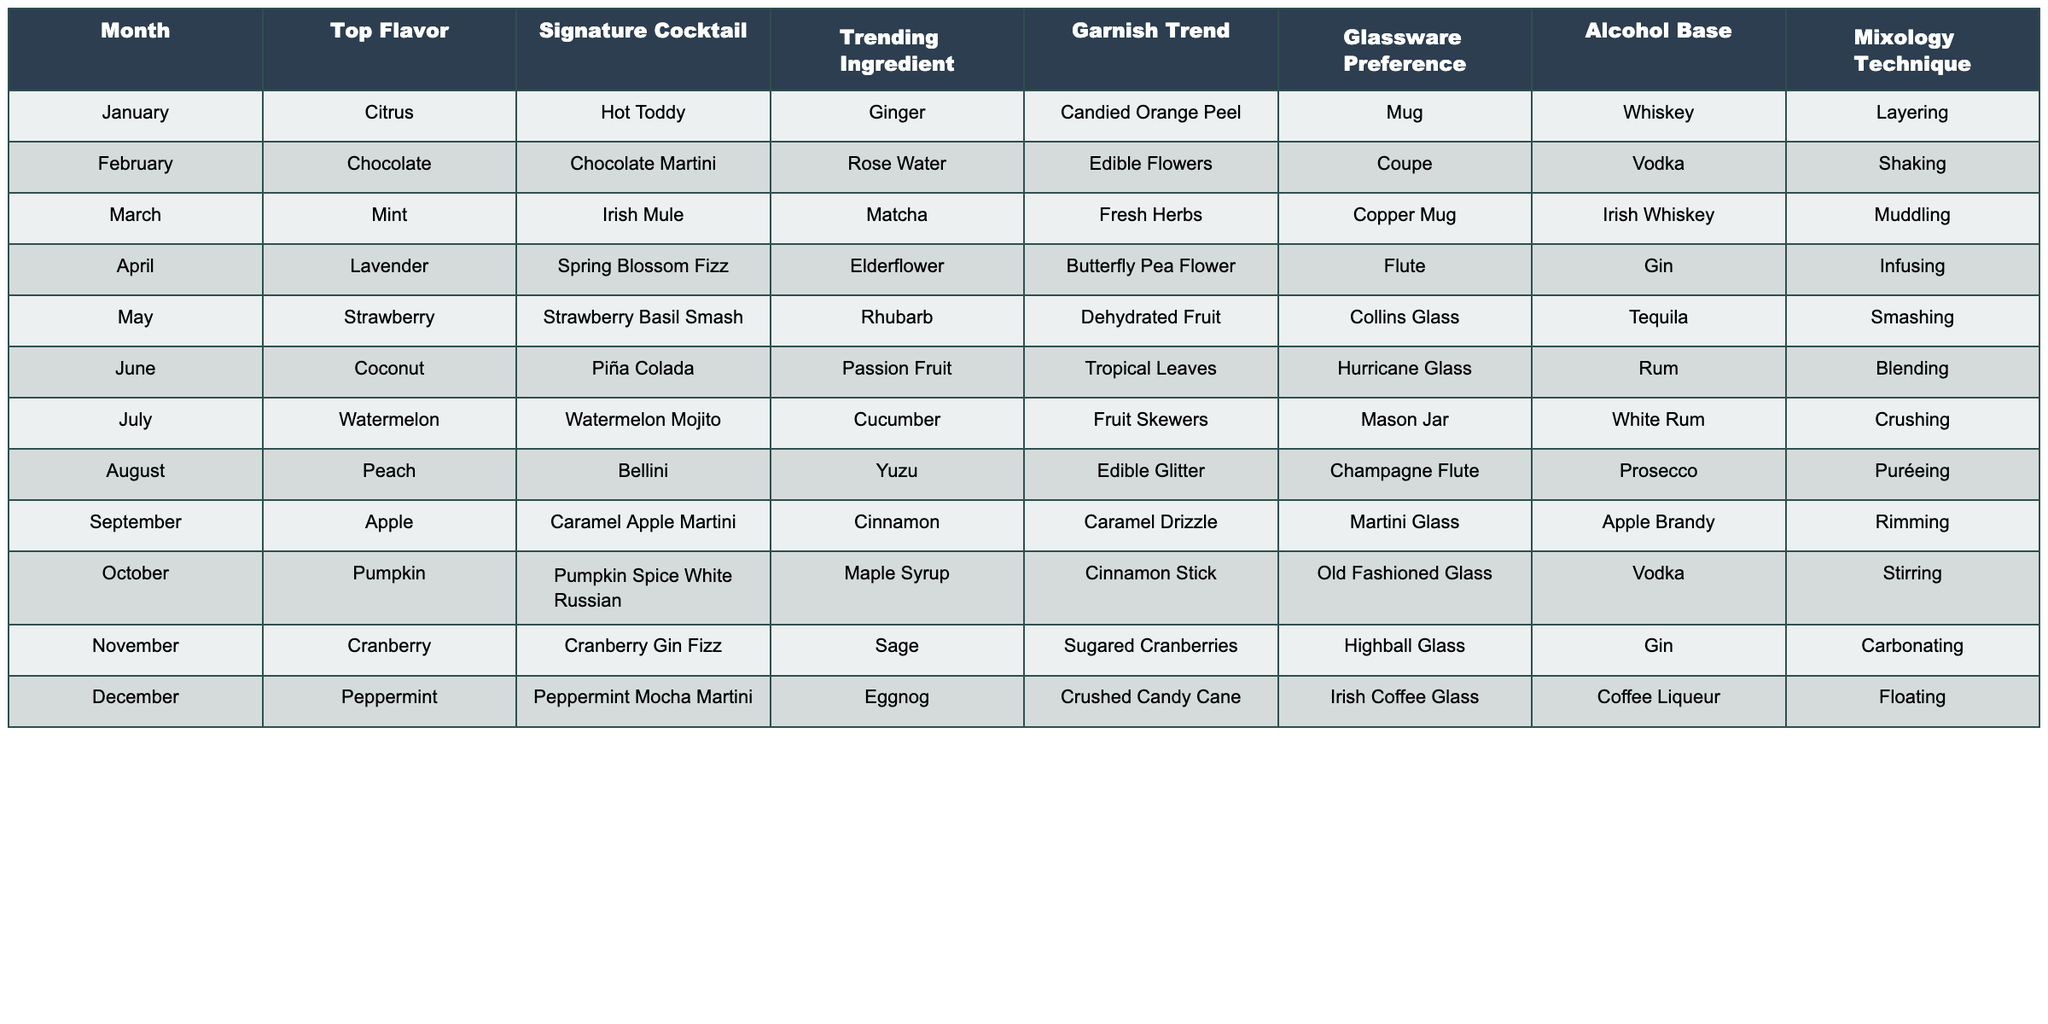What is the signature cocktail for July? The table indicates that the signature cocktail for July is the Watermelon Mojito.
Answer: Watermelon Mojito Which month has Coconut as a top flavor? By looking at the table, Coconut appears as the top flavor in June.
Answer: June Is Lavender a top flavor in any month? Checking the table, I see that Lavender is indeed a top flavor in April.
Answer: Yes What is the alcohol base used in the Pumpkin Spice White Russian? According to the table, the alcohol base for the Pumpkin Spice White Russian is Vodka.
Answer: Vodka Which cocktail uses Ginger as a trending ingredient? Referring to the table, the Hot Toddy uses Ginger as a trending ingredient, which is featured in January.
Answer: Hot Toddy In which month is the garnish trend of Fruit Skewers popular? The table shows that Fruit Skewers is the garnish trend for July.
Answer: July Which month has the highest number of different ingredients used in the trending ingredient column? Counting the entries in the trending ingredient column, all months seem to have one trending ingredient, making it equal across the board, hence no month stands out with more.
Answer: None What is the total number of different alcohol bases represented in the table? By examining the table, I note there are six different alcohol bases: Whiskey, Vodka, Irish Whiskey, Gin, Tequila, and Rum. Thus, the total count is six.
Answer: Six What is the difference in the glassware preference between August and September? The table lists Champagne Flute as the glassware preference for August and Martini Glass for September. The difference is that they are different types of glassware, but no numerical difference exists to quantify.
Answer: Different types Is the mixology technique for the Strawberry Basil Smash the same as that for the Piña Colada? The table shows that the Strawberry Basil Smash uses 'Smashing' while the Piña Colada uses 'Blending', indicating these are not the same technique.
Answer: No What is the average month-wise trend for garnishes that include fruits? Looking at the table, the months having fruit-based garnishes are July (Fruit Skewers) and May (Dehydrated Fruit). There's a total of 2 such months, so the average trend can be stated as having fruit garnishes in approximately 17% of the months (2 out of 12).
Answer: 17% 